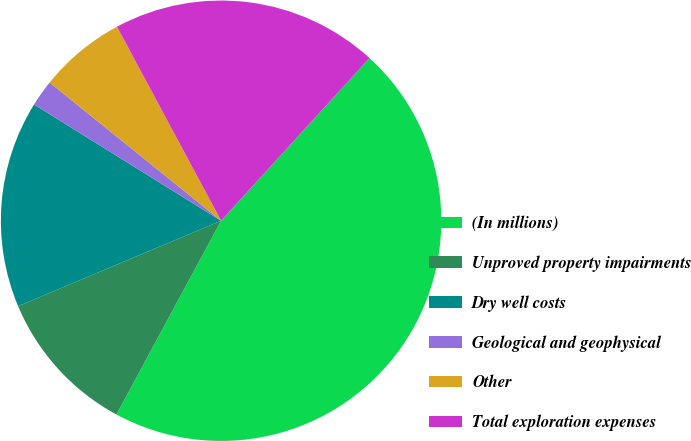Convert chart to OTSL. <chart><loc_0><loc_0><loc_500><loc_500><pie_chart><fcel>(In millions)<fcel>Unproved property impairments<fcel>Dry well costs<fcel>Geological and geophysical<fcel>Other<fcel>Total exploration expenses<nl><fcel>46.11%<fcel>10.78%<fcel>15.19%<fcel>1.95%<fcel>6.36%<fcel>19.61%<nl></chart> 